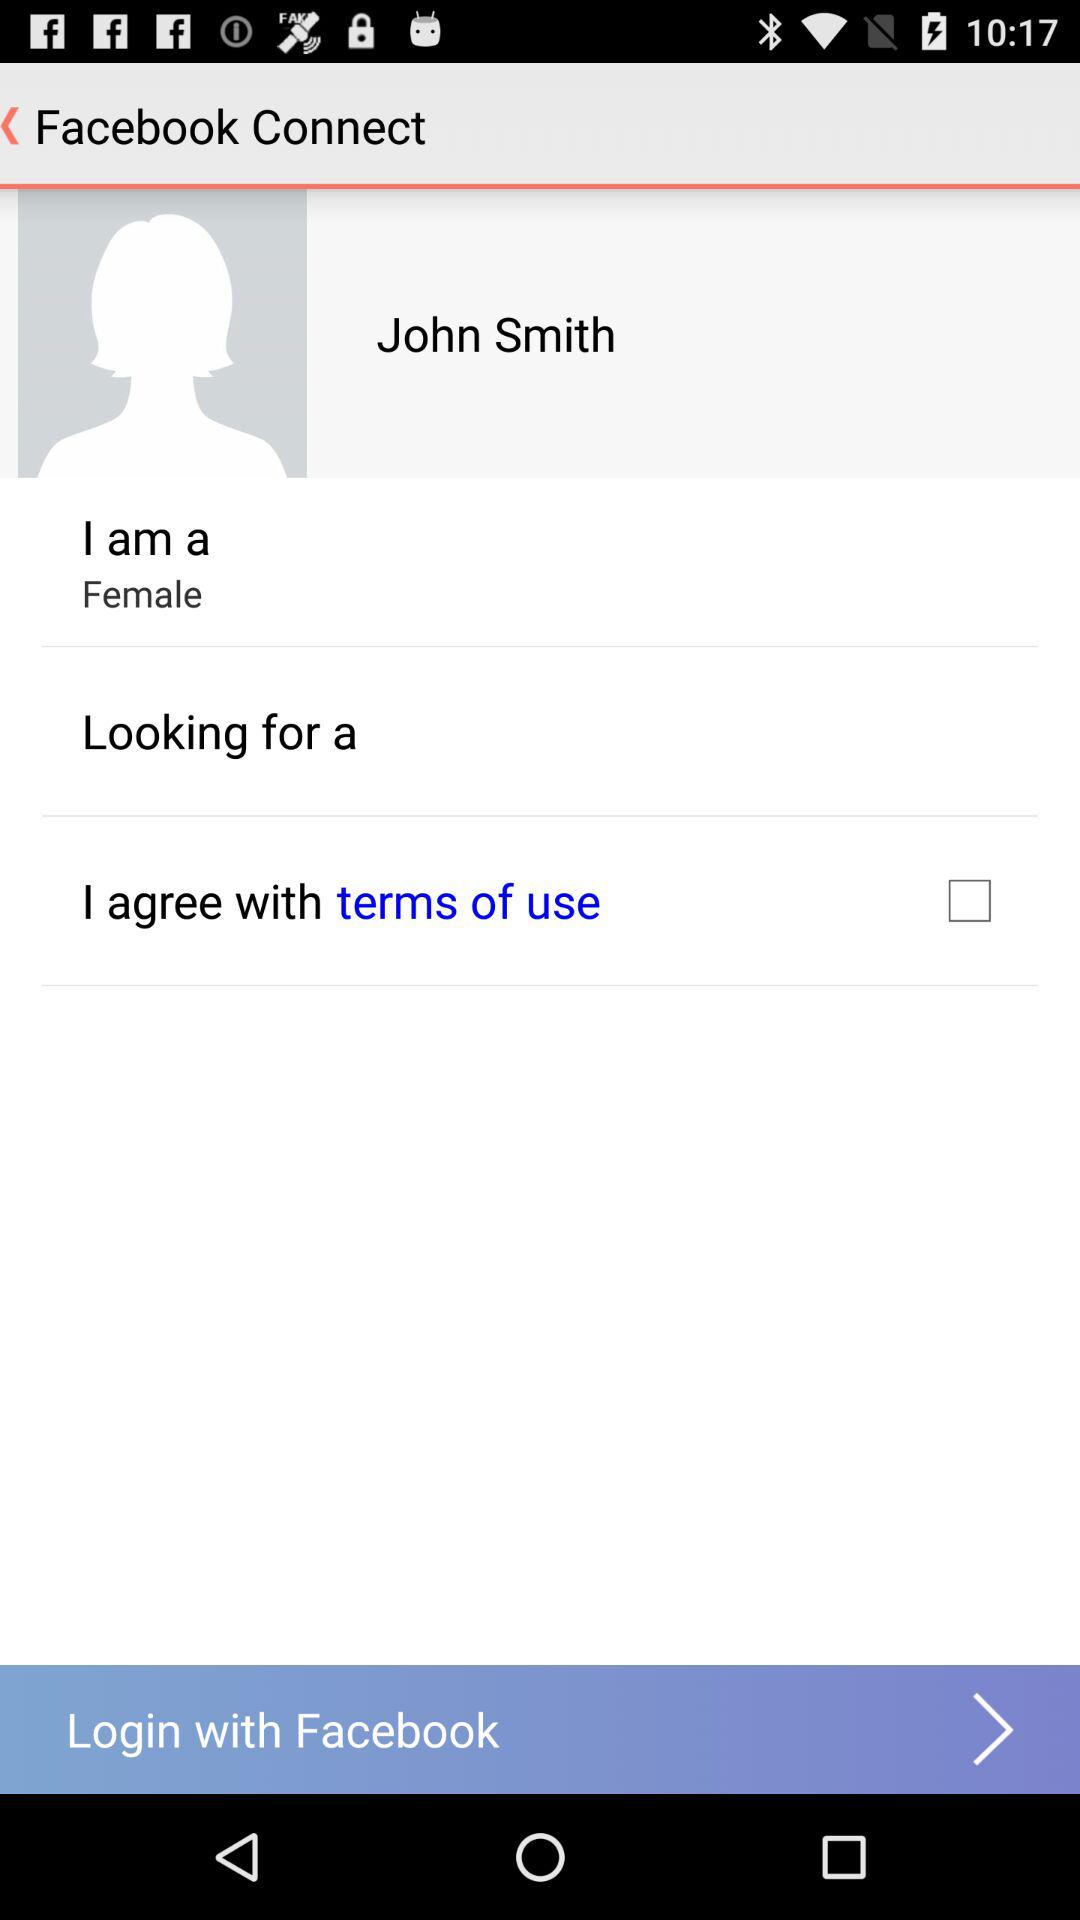How many female options are there?
Answer the question using a single word or phrase. 1 